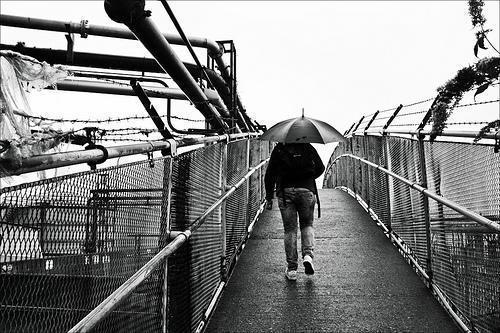How many umbrellas?
Give a very brief answer. 1. 